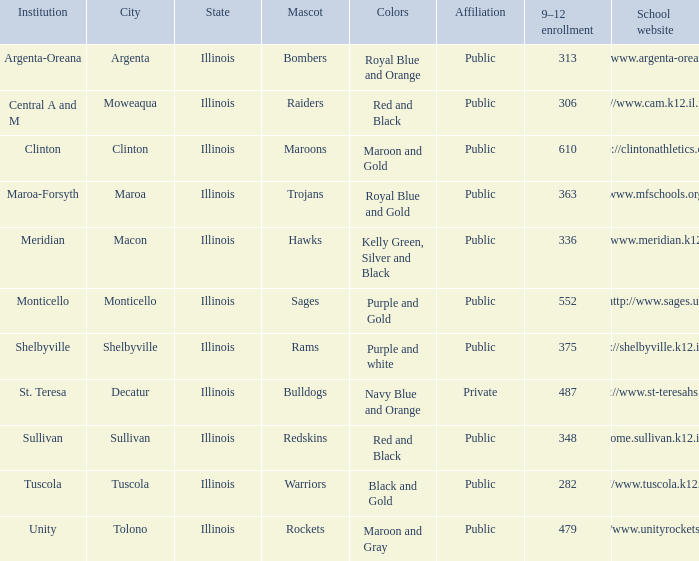How many different combinations of team colors are there in all the schools in Maroa, Illinois? 1.0. Can you give me this table as a dict? {'header': ['Institution', 'City', 'State', 'Mascot', 'Colors', 'Affiliation', '9–12 enrollment', 'School website'], 'rows': [['Argenta-Oreana', 'Argenta', 'Illinois', 'Bombers', 'Royal Blue and Orange', 'Public', '313', 'http://www.argenta-oreana.org'], ['Central A and M', 'Moweaqua', 'Illinois', 'Raiders', 'Red and Black', 'Public', '306', 'http://www.cam.k12.il.us/hs'], ['Clinton', 'Clinton', 'Illinois', 'Maroons', 'Maroon and Gold', 'Public', '610', 'http://clintonathletics.com'], ['Maroa-Forsyth', 'Maroa', 'Illinois', 'Trojans', 'Royal Blue and Gold', 'Public', '363', 'http://www.mfschools.org/high/'], ['Meridian', 'Macon', 'Illinois', 'Hawks', 'Kelly Green, Silver and Black', 'Public', '336', 'http://www.meridian.k12.il.us/'], ['Monticello', 'Monticello', 'Illinois', 'Sages', 'Purple and Gold', 'Public', '552', 'http://www.sages.us'], ['Shelbyville', 'Shelbyville', 'Illinois', 'Rams', 'Purple and white', 'Public', '375', 'http://shelbyville.k12.il.us/'], ['St. Teresa', 'Decatur', 'Illinois', 'Bulldogs', 'Navy Blue and Orange', 'Private', '487', 'http://www.st-teresahs.org/'], ['Sullivan', 'Sullivan', 'Illinois', 'Redskins', 'Red and Black', 'Public', '348', 'http://home.sullivan.k12.il.us/shs'], ['Tuscola', 'Tuscola', 'Illinois', 'Warriors', 'Black and Gold', 'Public', '282', 'http://www.tuscola.k12.il.us/'], ['Unity', 'Tolono', 'Illinois', 'Rockets', 'Maroon and Gray', 'Public', '479', 'http://www.unityrockets.com/']]} 